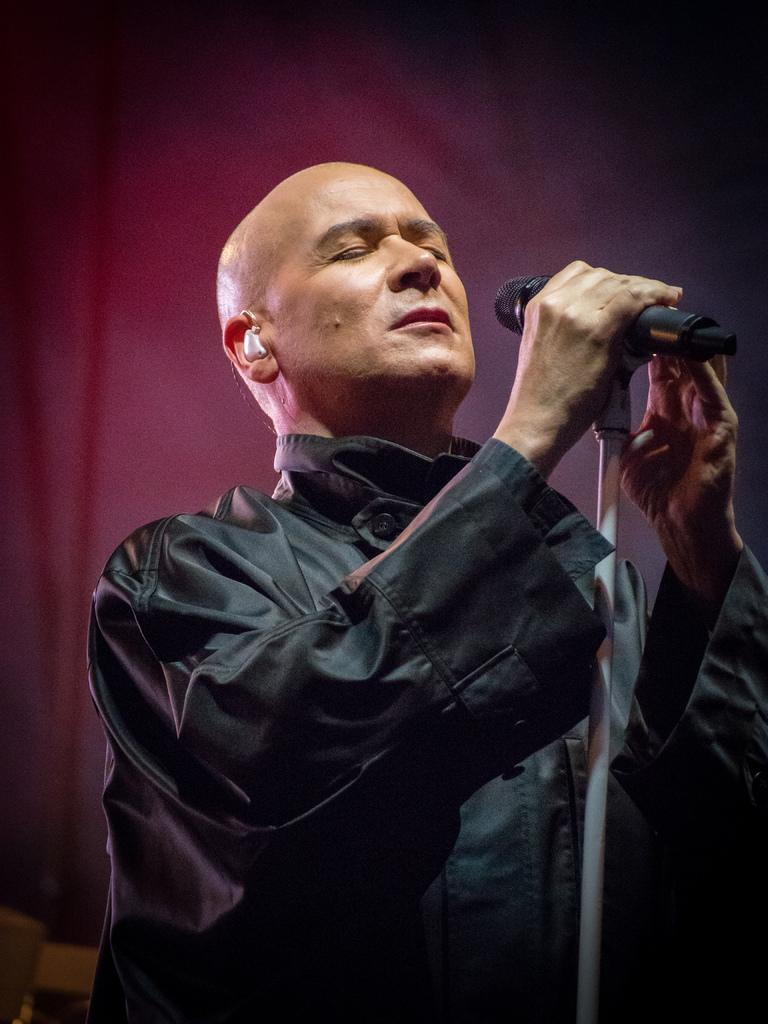What is the main subject of the image? There is a man in the image. What is the man wearing? The man is wearing a black dress. What is the man holding in his hands? The man is holding a microphone in his hands. What is the man's facial expression or action in the image? The man has his eyes closed. What can be seen in the background of the image? There is a curtain in the background of the image. How many mice are visible in the image? There are no mice present in the image. What type of voice does the man have in the image? The image does not provide any information about the man's voice. 